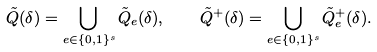Convert formula to latex. <formula><loc_0><loc_0><loc_500><loc_500>\tilde { Q } ( \delta ) = \bigcup _ { e \in \{ 0 , 1 \} ^ { s } } \tilde { Q } _ { e } ( \delta ) , \quad \tilde { Q } ^ { + } ( \delta ) = \bigcup _ { e \in \{ 0 , 1 \} ^ { s } } \tilde { Q } _ { e } ^ { + } ( \delta ) .</formula> 